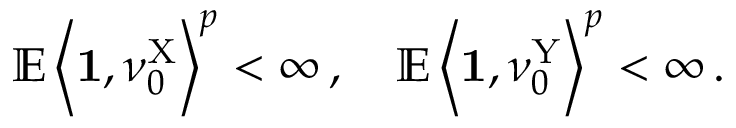<formula> <loc_0><loc_0><loc_500><loc_500>\mathbb { E } \left \langle 1 , \nu _ { 0 } ^ { X } \right \rangle ^ { p } < \infty \, , \quad \mathbb { E } \left \langle 1 , \nu _ { 0 } ^ { Y } \right \rangle ^ { p } < \infty \, .</formula> 